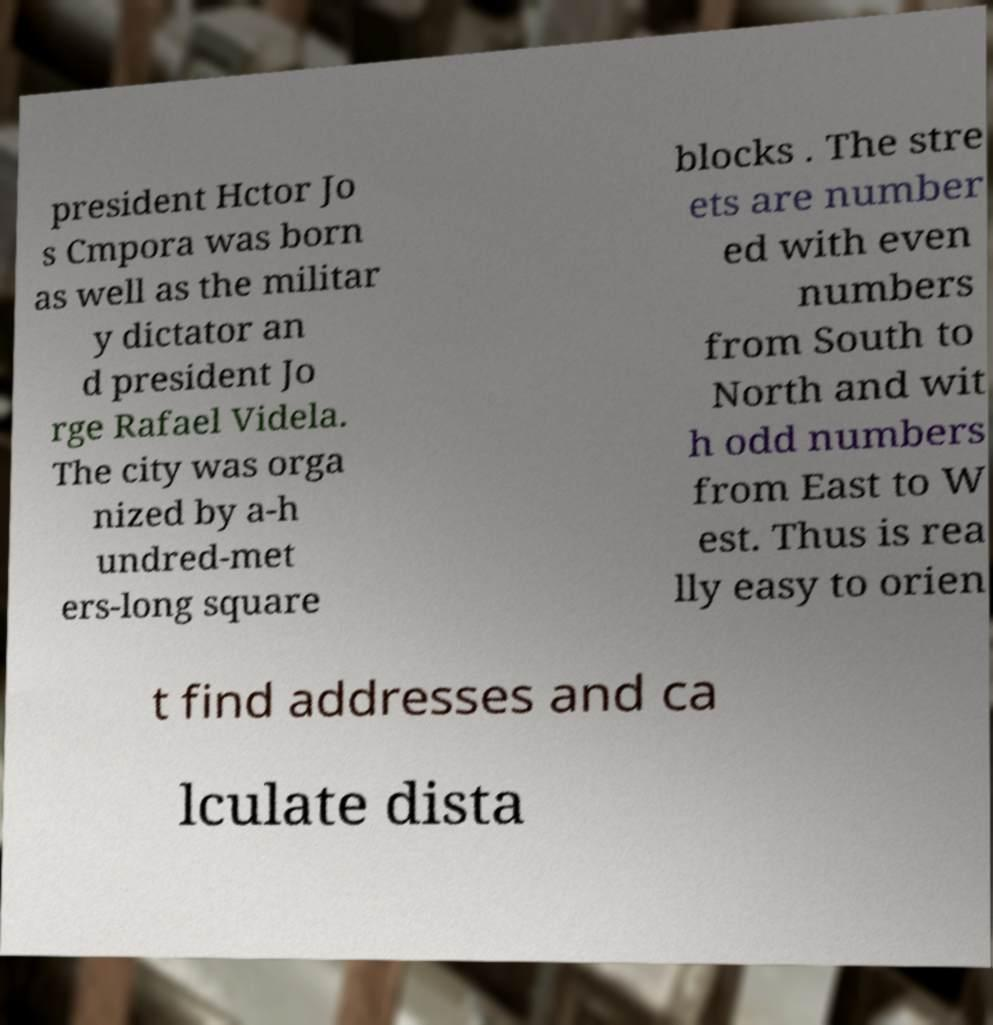There's text embedded in this image that I need extracted. Can you transcribe it verbatim? president Hctor Jo s Cmpora was born as well as the militar y dictator an d president Jo rge Rafael Videla. The city was orga nized by a-h undred-met ers-long square blocks . The stre ets are number ed with even numbers from South to North and wit h odd numbers from East to W est. Thus is rea lly easy to orien t find addresses and ca lculate dista 